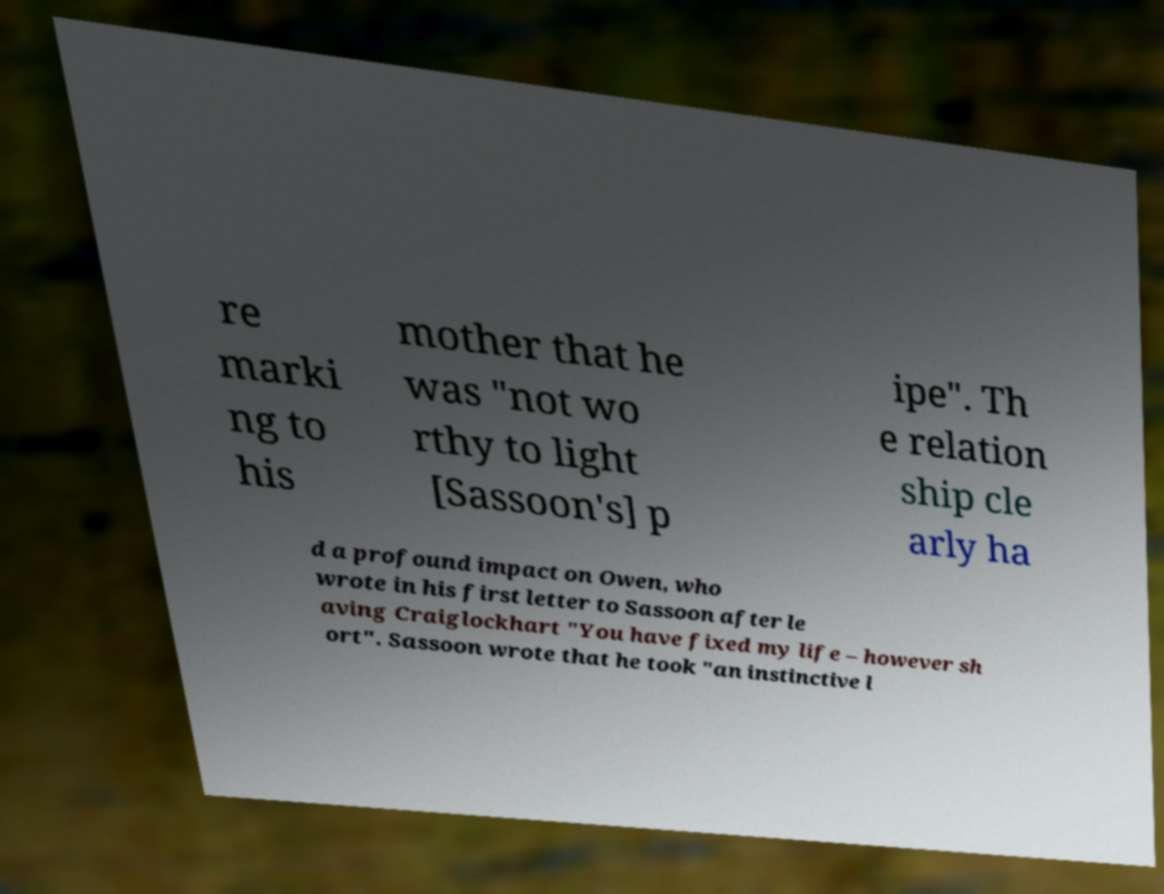There's text embedded in this image that I need extracted. Can you transcribe it verbatim? re marki ng to his mother that he was "not wo rthy to light [Sassoon's] p ipe". Th e relation ship cle arly ha d a profound impact on Owen, who wrote in his first letter to Sassoon after le aving Craiglockhart "You have fixed my life – however sh ort". Sassoon wrote that he took "an instinctive l 